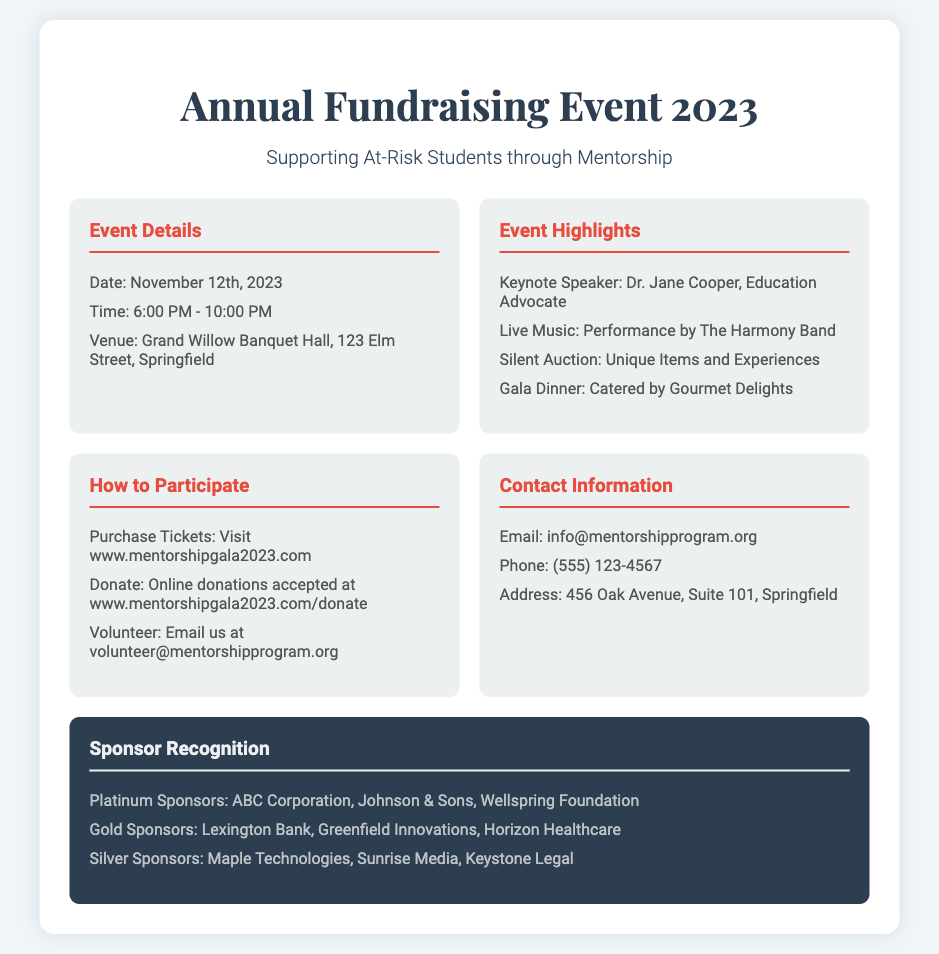what is the date of the event? The date is mentioned in the Event Details section of the document.
Answer: November 12th, 2023 who is the keynote speaker? The keynote speaker's name is listed under Event Highlights.
Answer: Dr. Jane Cooper what time does the event start? The start time is specified in the Event Details section.
Answer: 6:00 PM which venue is hosting the event? The venue name and address are found in the Event Details section.
Answer: Grand Willow Banquet Hall, 123 Elm Street, Springfield how can someone purchase tickets? The purchasing method is described in the How to Participate section.
Answer: Visit www.mentorshipgala2023.com how many levels of sponsorship are mentioned? The different levels can be counted in the Sponsor Recognition section.
Answer: Three what type of music will be performed? The type of music is mentioned alongside the live music event detail.
Answer: Live Music how can someone volunteer for the event? A specific action is described in the How to Participate section.
Answer: Email us at volunteer@mentorshipprogram.org what is the contact phone number for the mentorship program? The contact number can be found in the Contact Information section.
Answer: (555) 123-4567 